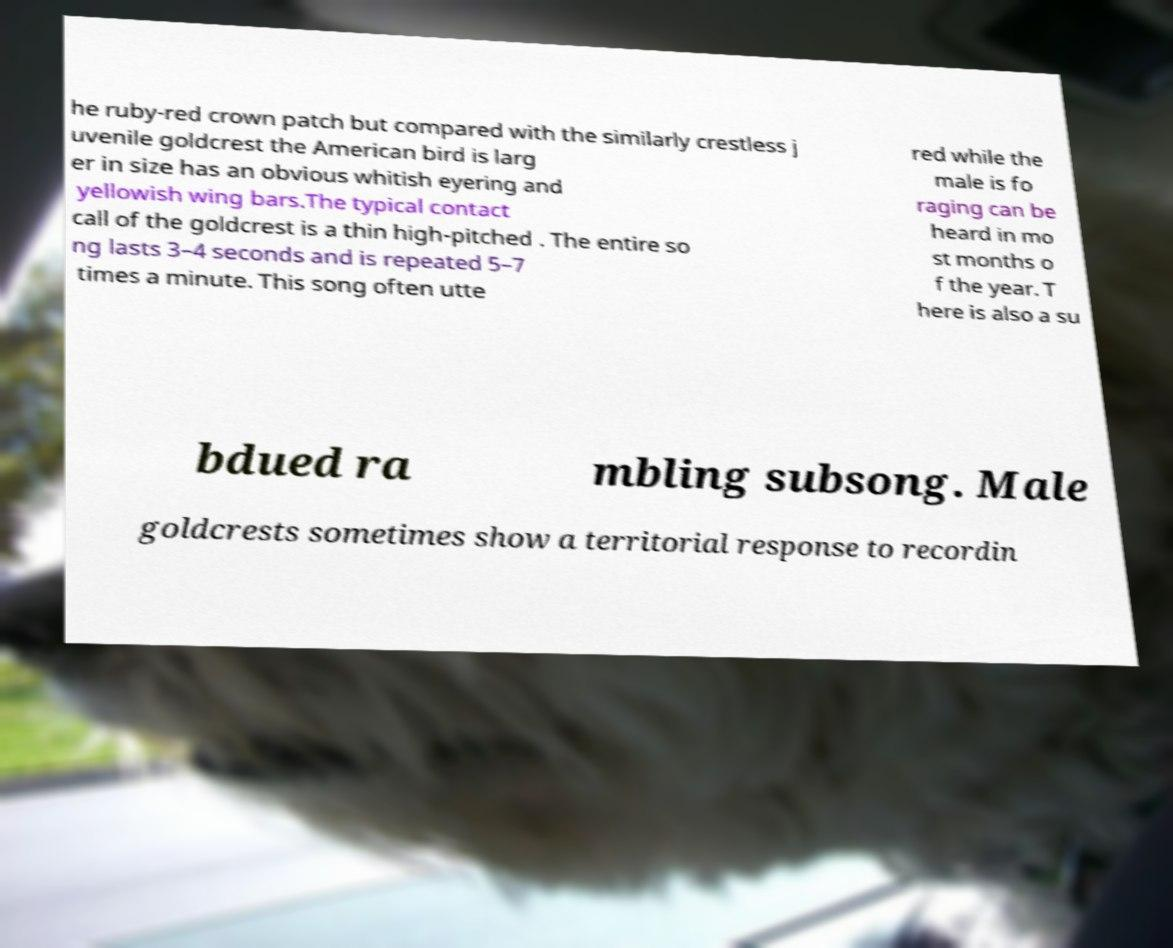Can you accurately transcribe the text from the provided image for me? he ruby-red crown patch but compared with the similarly crestless j uvenile goldcrest the American bird is larg er in size has an obvious whitish eyering and yellowish wing bars.The typical contact call of the goldcrest is a thin high-pitched . The entire so ng lasts 3–4 seconds and is repeated 5–7 times a minute. This song often utte red while the male is fo raging can be heard in mo st months o f the year. T here is also a su bdued ra mbling subsong. Male goldcrests sometimes show a territorial response to recordin 